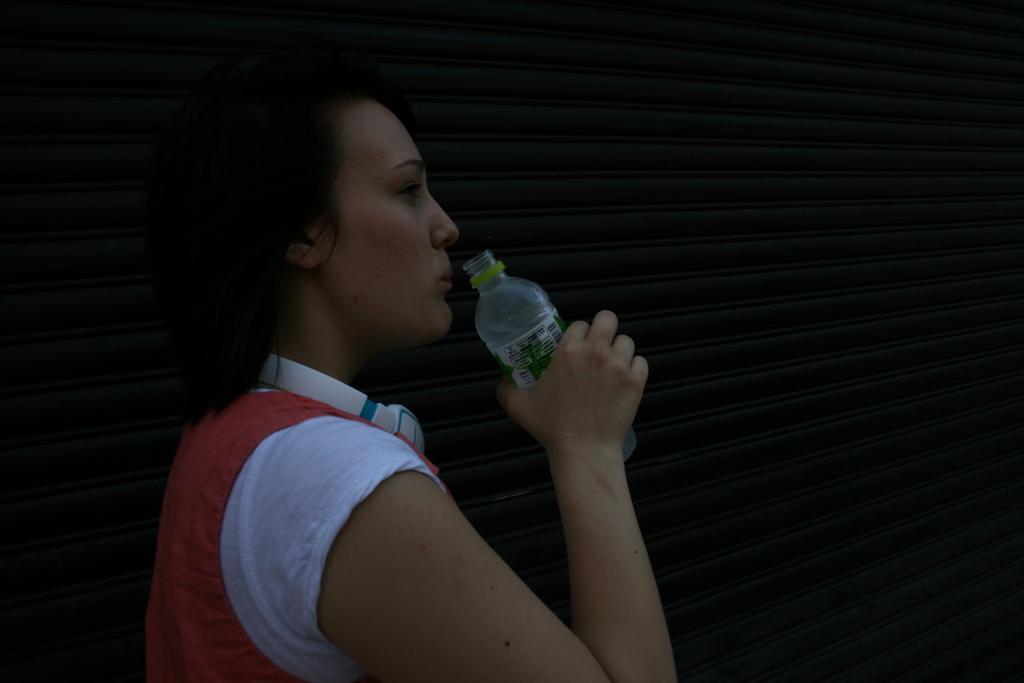In one or two sentences, can you explain what this image depicts? In this image I can see a woman holding a water bottle in her hand. 